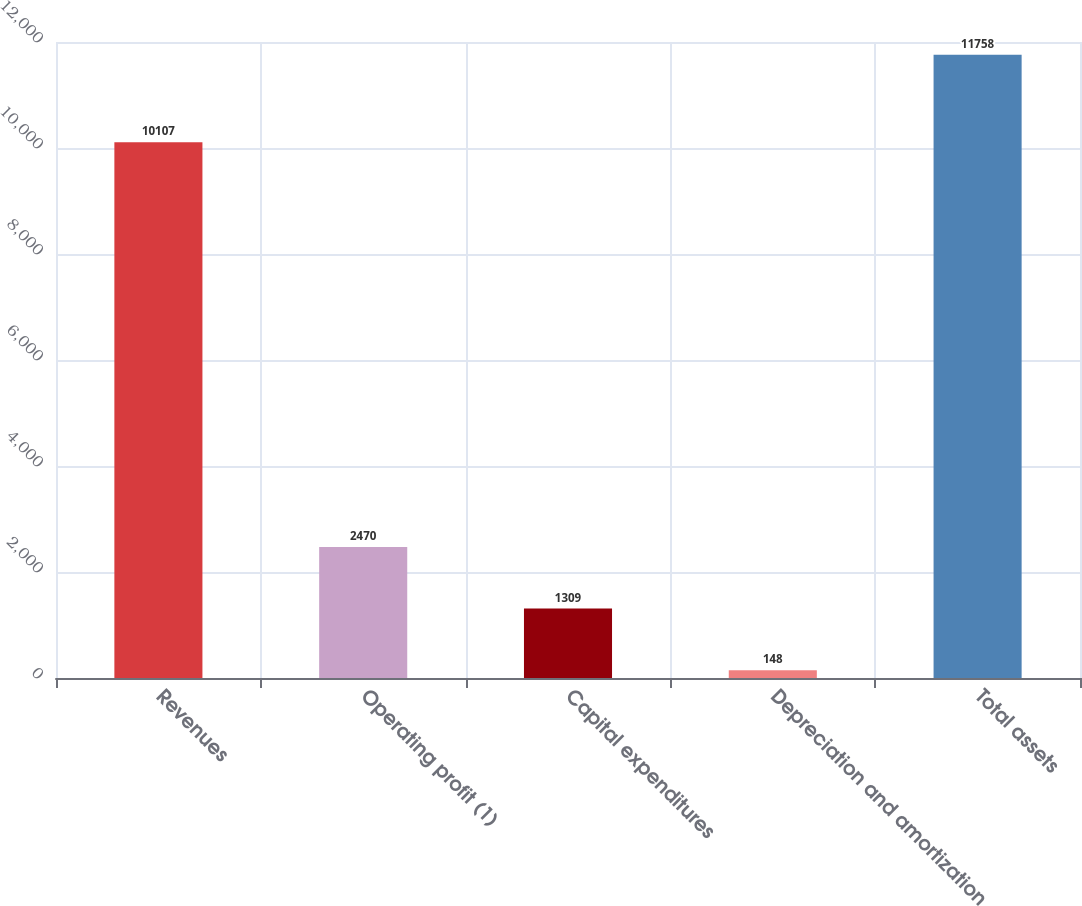Convert chart. <chart><loc_0><loc_0><loc_500><loc_500><bar_chart><fcel>Revenues<fcel>Operating profit (1)<fcel>Capital expenditures<fcel>Depreciation and amortization<fcel>Total assets<nl><fcel>10107<fcel>2470<fcel>1309<fcel>148<fcel>11758<nl></chart> 